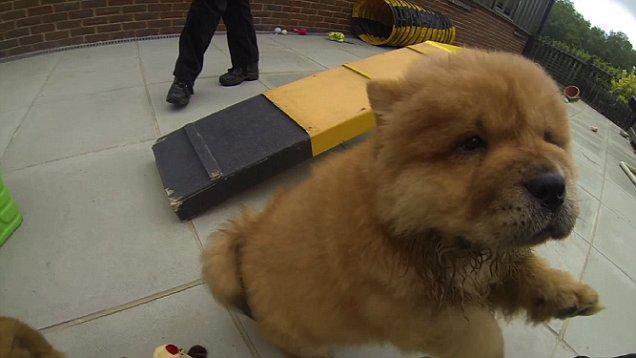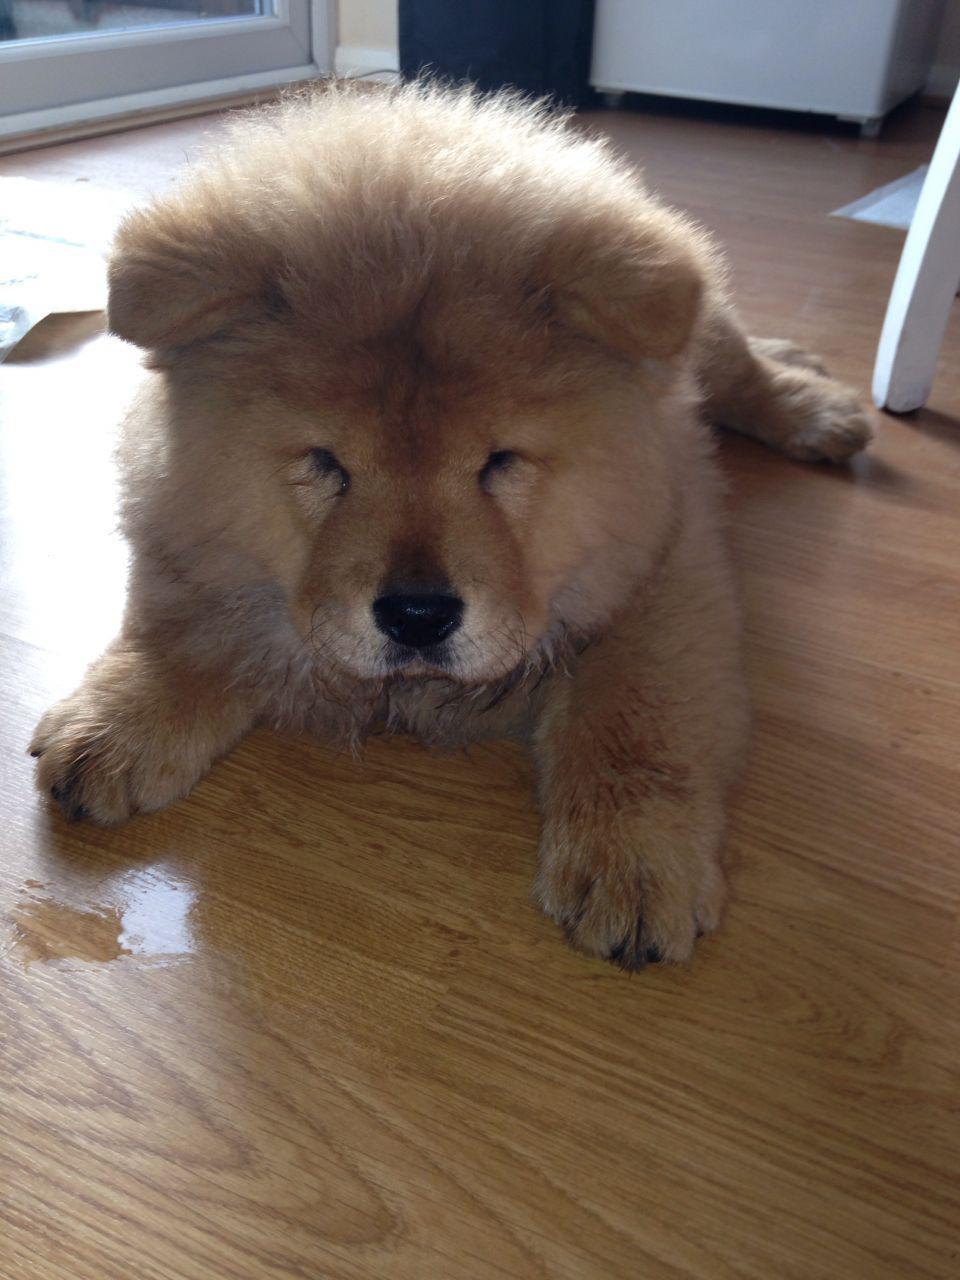The first image is the image on the left, the second image is the image on the right. Given the left and right images, does the statement "Exactly one chow dog is standing with all four paws on the ground." hold true? Answer yes or no. No. The first image is the image on the left, the second image is the image on the right. Considering the images on both sides, is "At least one of the dogs is being handled by a human; either by leash or by grip." valid? Answer yes or no. No. 